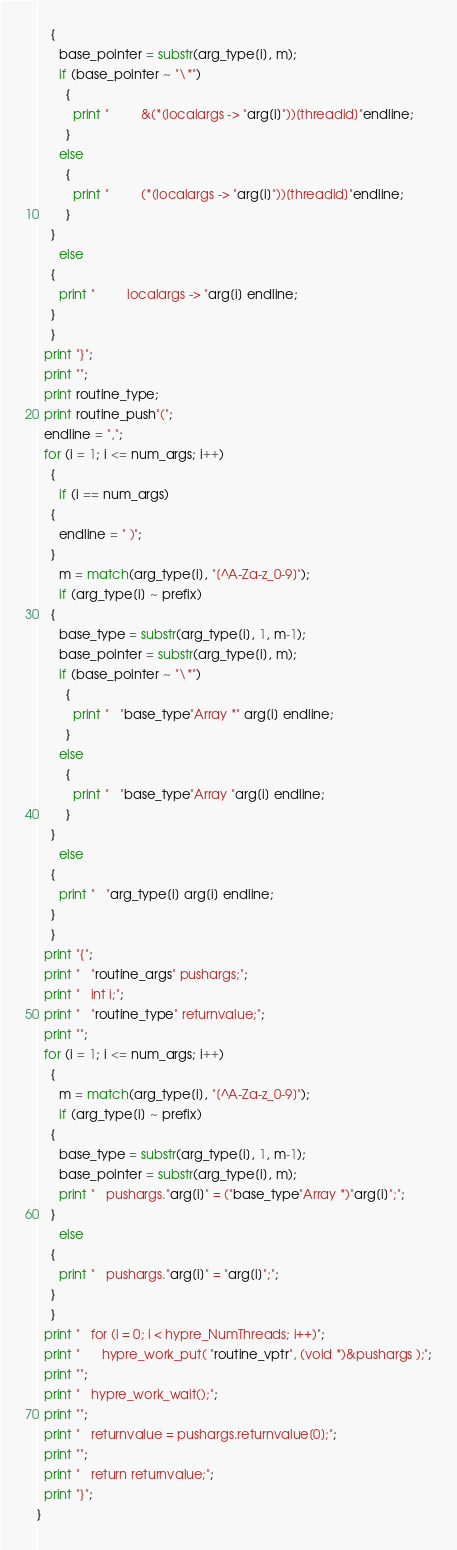<code> <loc_0><loc_0><loc_500><loc_500><_Awk_>	{
	  base_pointer = substr(arg_type[i], m);
	  if (base_pointer ~ "\*")
	    {
	      print "         &(*(localargs -> "arg[i]"))[threadid]"endline;
	    }
	  else
	    {
	      print "         (*(localargs -> "arg[i]"))[threadid]"endline;
	    }
	}
      else
	{
	  print "         localargs -> "arg[i] endline;
	}
    }
  print "}";
  print "";
  print routine_type;
  print routine_push"(";
  endline = ",";
  for (i = 1; i <= num_args; i++)
    {
      if (i == num_args)
	{
	  endline = " )";
	}
      m = match(arg_type[i], "[^A-Za-z_0-9]");
      if (arg_type[i] ~ prefix)
	{
	  base_type = substr(arg_type[i], 1, m-1);
	  base_pointer = substr(arg_type[i], m);
	  if (base_pointer ~ "\*")
	    {
	      print "   "base_type"Array *" arg[i] endline;
	    }
	  else
	    {
	      print "   "base_type"Array "arg[i] endline;
	    }
	}
      else
	{
	  print "   "arg_type[i] arg[i] endline;
	}
    }
  print "{";
  print "   "routine_args" pushargs;";
  print "   int i;";
  print "   "routine_type" returnvalue;";
  print "";
  for (i = 1; i <= num_args; i++)
    {
      m = match(arg_type[i], "[^A-Za-z_0-9]");
      if (arg_type[i] ~ prefix)
	{
	  base_type = substr(arg_type[i], 1, m-1);
	  base_pointer = substr(arg_type[i], m);
	  print "   pushargs."arg[i]" = ("base_type"Array *)"arg[i]";";
	}
      else
	{
	  print "   pushargs."arg[i]" = "arg[i]";";
	}
    }
  print "   for (i = 0; i < hypre_NumThreads; i++)";
  print "      hypre_work_put( "routine_vptr", (void *)&pushargs );";
  print "";
  print "   hypre_work_wait();";
  print "";
  print "   returnvalue = pushargs.returnvalue[0];";
  print "";
  print "   return returnvalue;";
  print "}";
}


</code> 